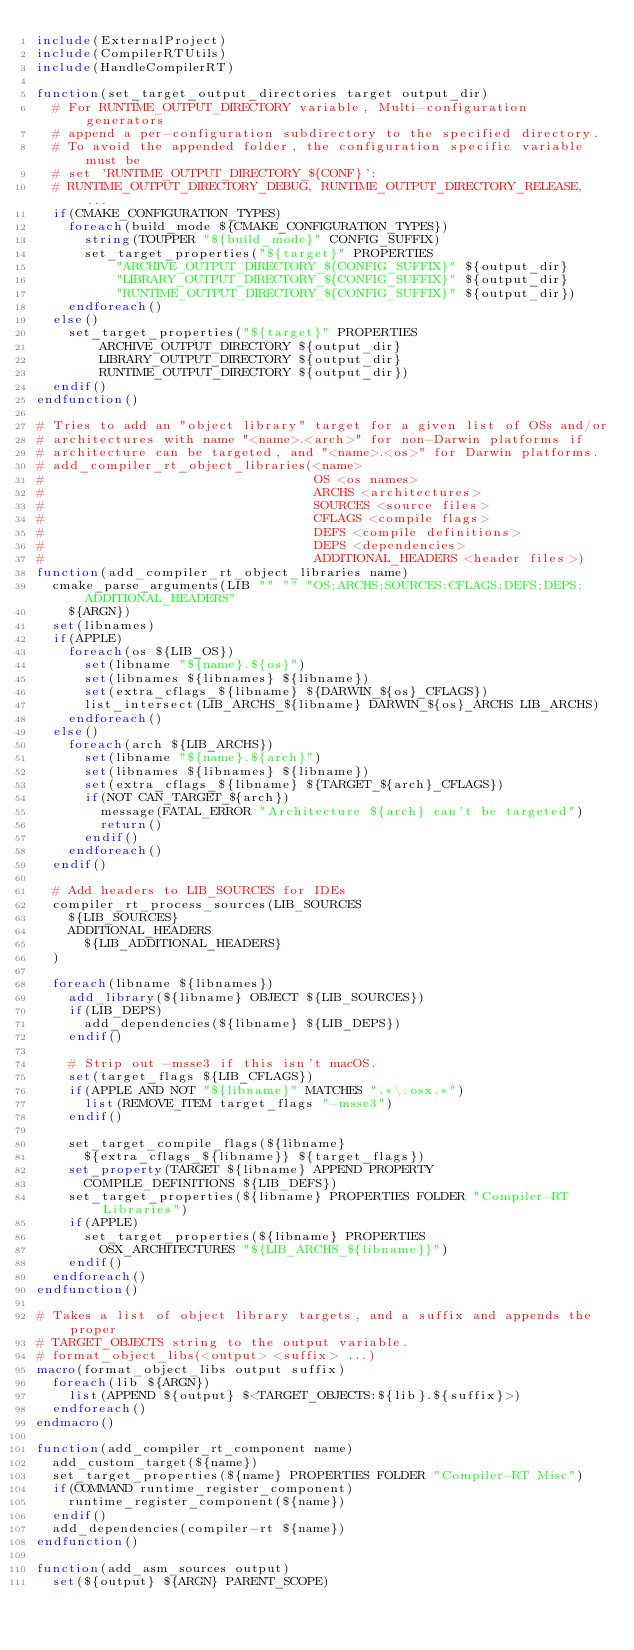<code> <loc_0><loc_0><loc_500><loc_500><_CMake_>include(ExternalProject)
include(CompilerRTUtils)
include(HandleCompilerRT)

function(set_target_output_directories target output_dir)
  # For RUNTIME_OUTPUT_DIRECTORY variable, Multi-configuration generators
  # append a per-configuration subdirectory to the specified directory.
  # To avoid the appended folder, the configuration specific variable must be
  # set 'RUNTIME_OUTPUT_DIRECTORY_${CONF}':
  # RUNTIME_OUTPUT_DIRECTORY_DEBUG, RUNTIME_OUTPUT_DIRECTORY_RELEASE, ...
  if(CMAKE_CONFIGURATION_TYPES)
    foreach(build_mode ${CMAKE_CONFIGURATION_TYPES})
      string(TOUPPER "${build_mode}" CONFIG_SUFFIX)
      set_target_properties("${target}" PROPERTIES
          "ARCHIVE_OUTPUT_DIRECTORY_${CONFIG_SUFFIX}" ${output_dir}
          "LIBRARY_OUTPUT_DIRECTORY_${CONFIG_SUFFIX}" ${output_dir}
          "RUNTIME_OUTPUT_DIRECTORY_${CONFIG_SUFFIX}" ${output_dir})
    endforeach()
  else()
    set_target_properties("${target}" PROPERTIES
        ARCHIVE_OUTPUT_DIRECTORY ${output_dir}
        LIBRARY_OUTPUT_DIRECTORY ${output_dir}
        RUNTIME_OUTPUT_DIRECTORY ${output_dir})
  endif()
endfunction()

# Tries to add an "object library" target for a given list of OSs and/or
# architectures with name "<name>.<arch>" for non-Darwin platforms if
# architecture can be targeted, and "<name>.<os>" for Darwin platforms.
# add_compiler_rt_object_libraries(<name>
#                                  OS <os names>
#                                  ARCHS <architectures>
#                                  SOURCES <source files>
#                                  CFLAGS <compile flags>
#                                  DEFS <compile definitions>
#                                  DEPS <dependencies>
#                                  ADDITIONAL_HEADERS <header files>)
function(add_compiler_rt_object_libraries name)
  cmake_parse_arguments(LIB "" "" "OS;ARCHS;SOURCES;CFLAGS;DEFS;DEPS;ADDITIONAL_HEADERS"
    ${ARGN})
  set(libnames)
  if(APPLE)
    foreach(os ${LIB_OS})
      set(libname "${name}.${os}")
      set(libnames ${libnames} ${libname})
      set(extra_cflags_${libname} ${DARWIN_${os}_CFLAGS})
      list_intersect(LIB_ARCHS_${libname} DARWIN_${os}_ARCHS LIB_ARCHS)
    endforeach()
  else()
    foreach(arch ${LIB_ARCHS})
      set(libname "${name}.${arch}")
      set(libnames ${libnames} ${libname})
      set(extra_cflags_${libname} ${TARGET_${arch}_CFLAGS})
      if(NOT CAN_TARGET_${arch})
        message(FATAL_ERROR "Architecture ${arch} can't be targeted")
        return()
      endif()
    endforeach()
  endif()

  # Add headers to LIB_SOURCES for IDEs
  compiler_rt_process_sources(LIB_SOURCES
    ${LIB_SOURCES}
    ADDITIONAL_HEADERS
      ${LIB_ADDITIONAL_HEADERS}
  )

  foreach(libname ${libnames})
    add_library(${libname} OBJECT ${LIB_SOURCES})
    if(LIB_DEPS)
      add_dependencies(${libname} ${LIB_DEPS})
    endif()

    # Strip out -msse3 if this isn't macOS.
    set(target_flags ${LIB_CFLAGS})
    if(APPLE AND NOT "${libname}" MATCHES ".*\.osx.*")
      list(REMOVE_ITEM target_flags "-msse3")
    endif()

    set_target_compile_flags(${libname}
      ${extra_cflags_${libname}} ${target_flags})
    set_property(TARGET ${libname} APPEND PROPERTY
      COMPILE_DEFINITIONS ${LIB_DEFS})
    set_target_properties(${libname} PROPERTIES FOLDER "Compiler-RT Libraries")
    if(APPLE)
      set_target_properties(${libname} PROPERTIES
        OSX_ARCHITECTURES "${LIB_ARCHS_${libname}}")
    endif()
  endforeach()
endfunction()

# Takes a list of object library targets, and a suffix and appends the proper
# TARGET_OBJECTS string to the output variable.
# format_object_libs(<output> <suffix> ...)
macro(format_object_libs output suffix)
  foreach(lib ${ARGN})
    list(APPEND ${output} $<TARGET_OBJECTS:${lib}.${suffix}>)
  endforeach()
endmacro()

function(add_compiler_rt_component name)
  add_custom_target(${name})
  set_target_properties(${name} PROPERTIES FOLDER "Compiler-RT Misc")
  if(COMMAND runtime_register_component)
    runtime_register_component(${name})
  endif()
  add_dependencies(compiler-rt ${name})
endfunction()

function(add_asm_sources output)
  set(${output} ${ARGN} PARENT_SCOPE)</code> 